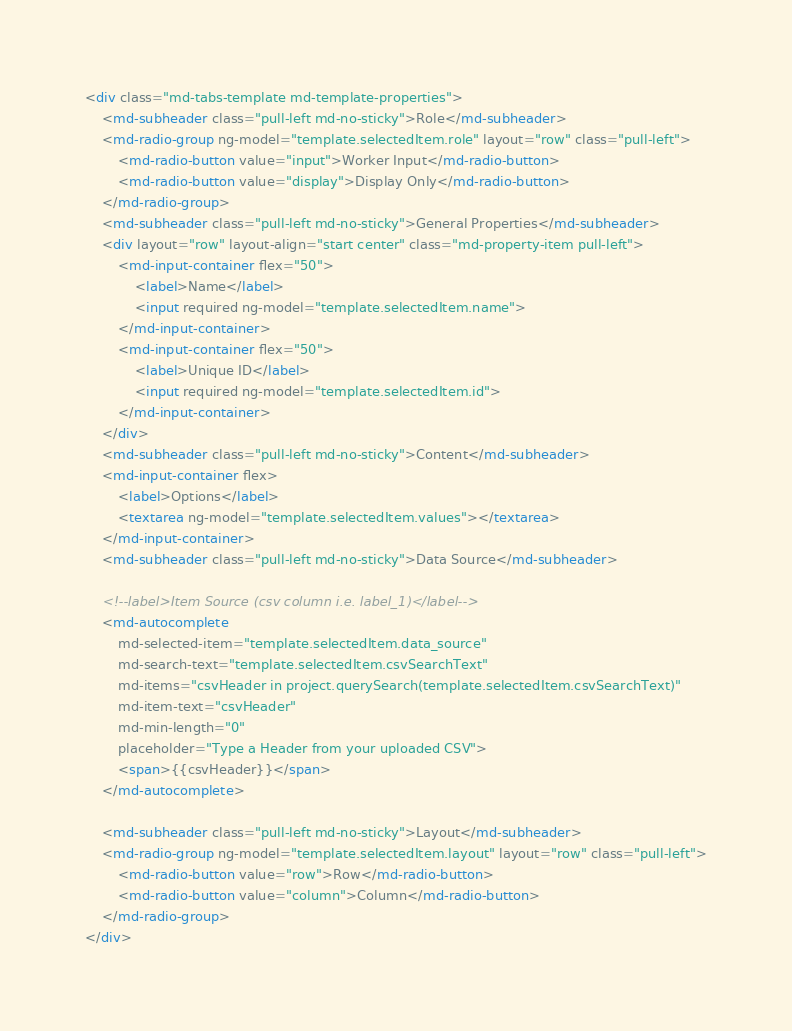Convert code to text. <code><loc_0><loc_0><loc_500><loc_500><_HTML_><div class="md-tabs-template md-template-properties">
    <md-subheader class="pull-left md-no-sticky">Role</md-subheader>
    <md-radio-group ng-model="template.selectedItem.role" layout="row" class="pull-left">
        <md-radio-button value="input">Worker Input</md-radio-button>
        <md-radio-button value="display">Display Only</md-radio-button>
    </md-radio-group>
    <md-subheader class="pull-left md-no-sticky">General Properties</md-subheader>
    <div layout="row" layout-align="start center" class="md-property-item pull-left">
        <md-input-container flex="50">
            <label>Name</label>
            <input required ng-model="template.selectedItem.name">
        </md-input-container>
        <md-input-container flex="50">
            <label>Unique ID</label>
            <input required ng-model="template.selectedItem.id">
        </md-input-container>
    </div>
    <md-subheader class="pull-left md-no-sticky">Content</md-subheader>
    <md-input-container flex>
        <label>Options</label>
        <textarea ng-model="template.selectedItem.values"></textarea>
    </md-input-container>
    <md-subheader class="pull-left md-no-sticky">Data Source</md-subheader>

    <!--label>Item Source (csv column i.e. label_1)</label-->
    <md-autocomplete
        md-selected-item="template.selectedItem.data_source"
        md-search-text="template.selectedItem.csvSearchText"
        md-items="csvHeader in project.querySearch(template.selectedItem.csvSearchText)"
        md-item-text="csvHeader"
        md-min-length="0"
        placeholder="Type a Header from your uploaded CSV">
        <span>{{csvHeader}}</span>
    </md-autocomplete>

    <md-subheader class="pull-left md-no-sticky">Layout</md-subheader>
    <md-radio-group ng-model="template.selectedItem.layout" layout="row" class="pull-left">
        <md-radio-button value="row">Row</md-radio-button>
        <md-radio-button value="column">Column</md-radio-button>
    </md-radio-group>
</div>

</code> 